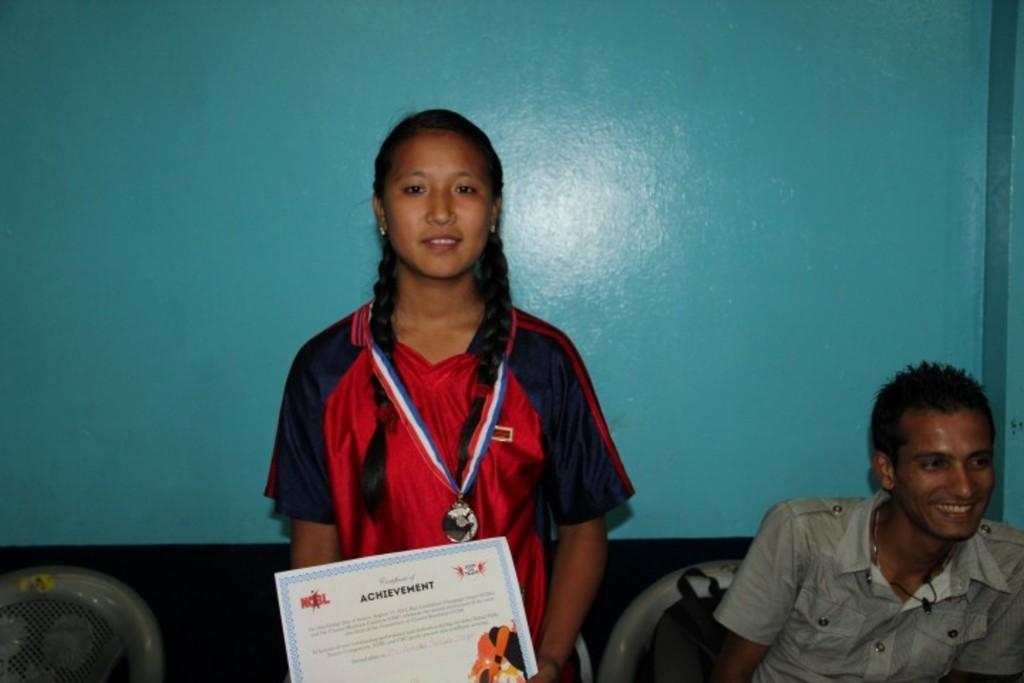Can you describe this image briefly? In the background we can see the wall. We can see chairs. We can see a girl wearing a medal and she is holding a certificate and smiling. Beside to her we can see a man sitting on the chair. We can see a bag on the chair. 